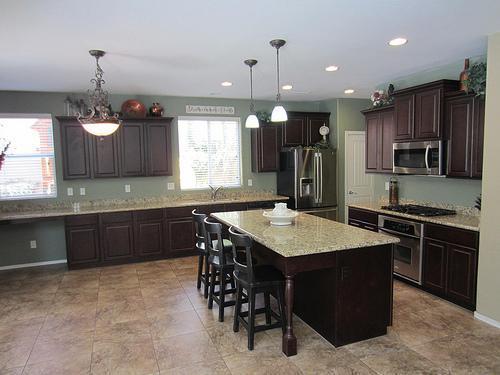How many chairs are there?
Give a very brief answer. 3. How many windows are there?
Give a very brief answer. 2. 